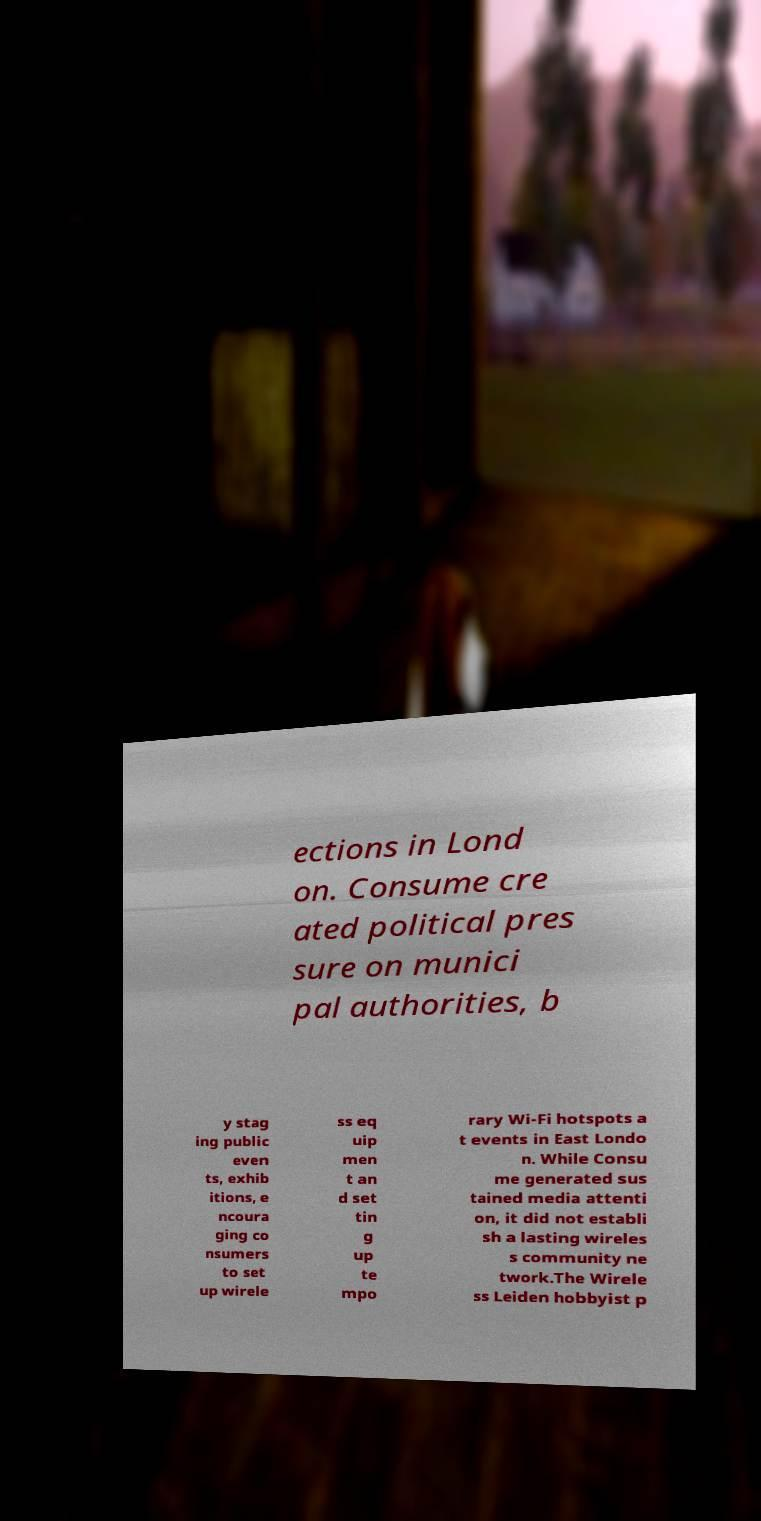There's text embedded in this image that I need extracted. Can you transcribe it verbatim? ections in Lond on. Consume cre ated political pres sure on munici pal authorities, b y stag ing public even ts, exhib itions, e ncoura ging co nsumers to set up wirele ss eq uip men t an d set tin g up te mpo rary Wi-Fi hotspots a t events in East Londo n. While Consu me generated sus tained media attenti on, it did not establi sh a lasting wireles s community ne twork.The Wirele ss Leiden hobbyist p 